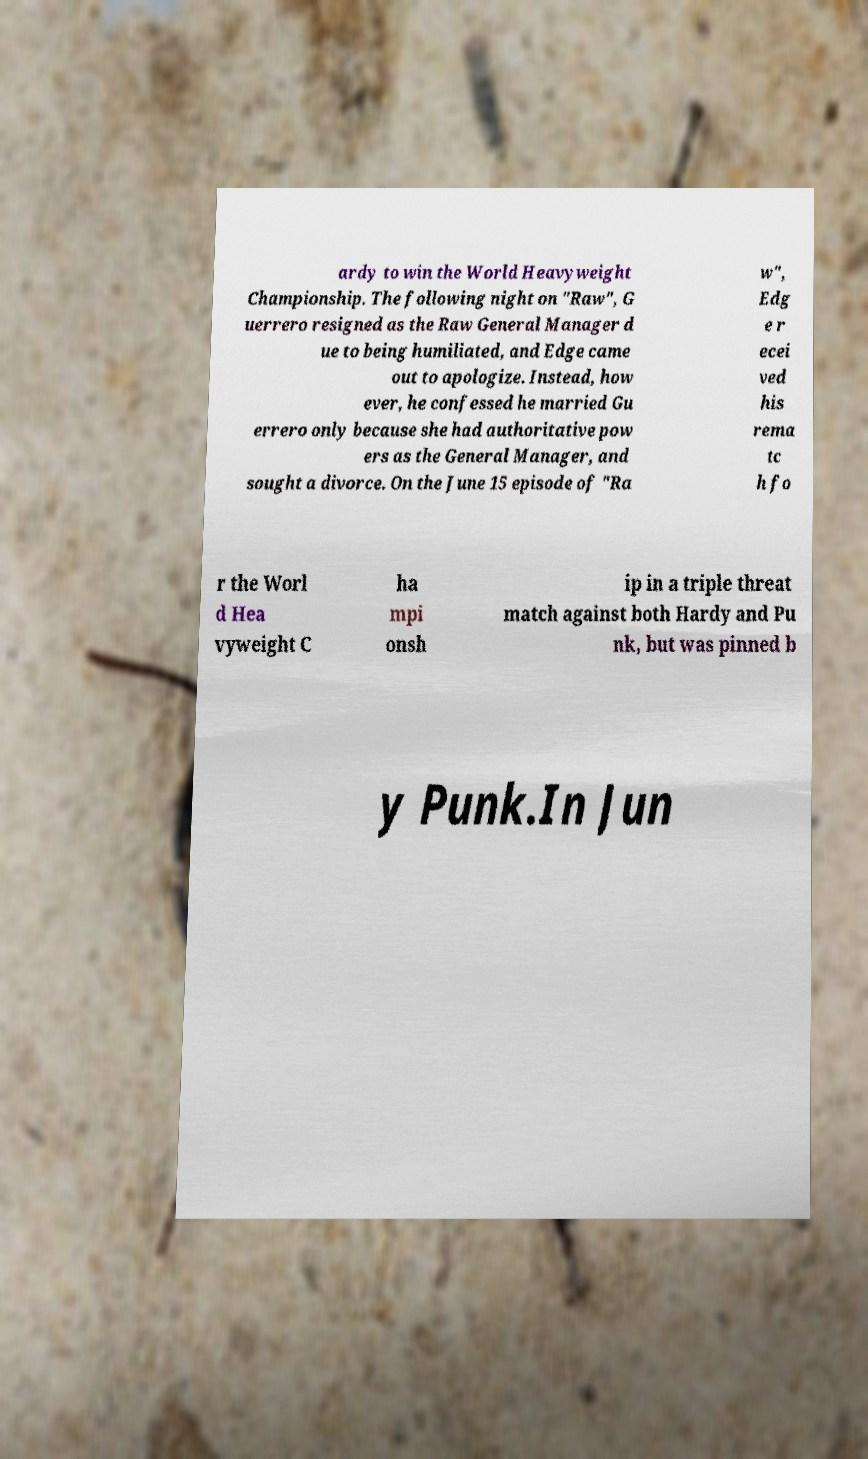Could you assist in decoding the text presented in this image and type it out clearly? ardy to win the World Heavyweight Championship. The following night on "Raw", G uerrero resigned as the Raw General Manager d ue to being humiliated, and Edge came out to apologize. Instead, how ever, he confessed he married Gu errero only because she had authoritative pow ers as the General Manager, and sought a divorce. On the June 15 episode of "Ra w", Edg e r ecei ved his rema tc h fo r the Worl d Hea vyweight C ha mpi onsh ip in a triple threat match against both Hardy and Pu nk, but was pinned b y Punk.In Jun 